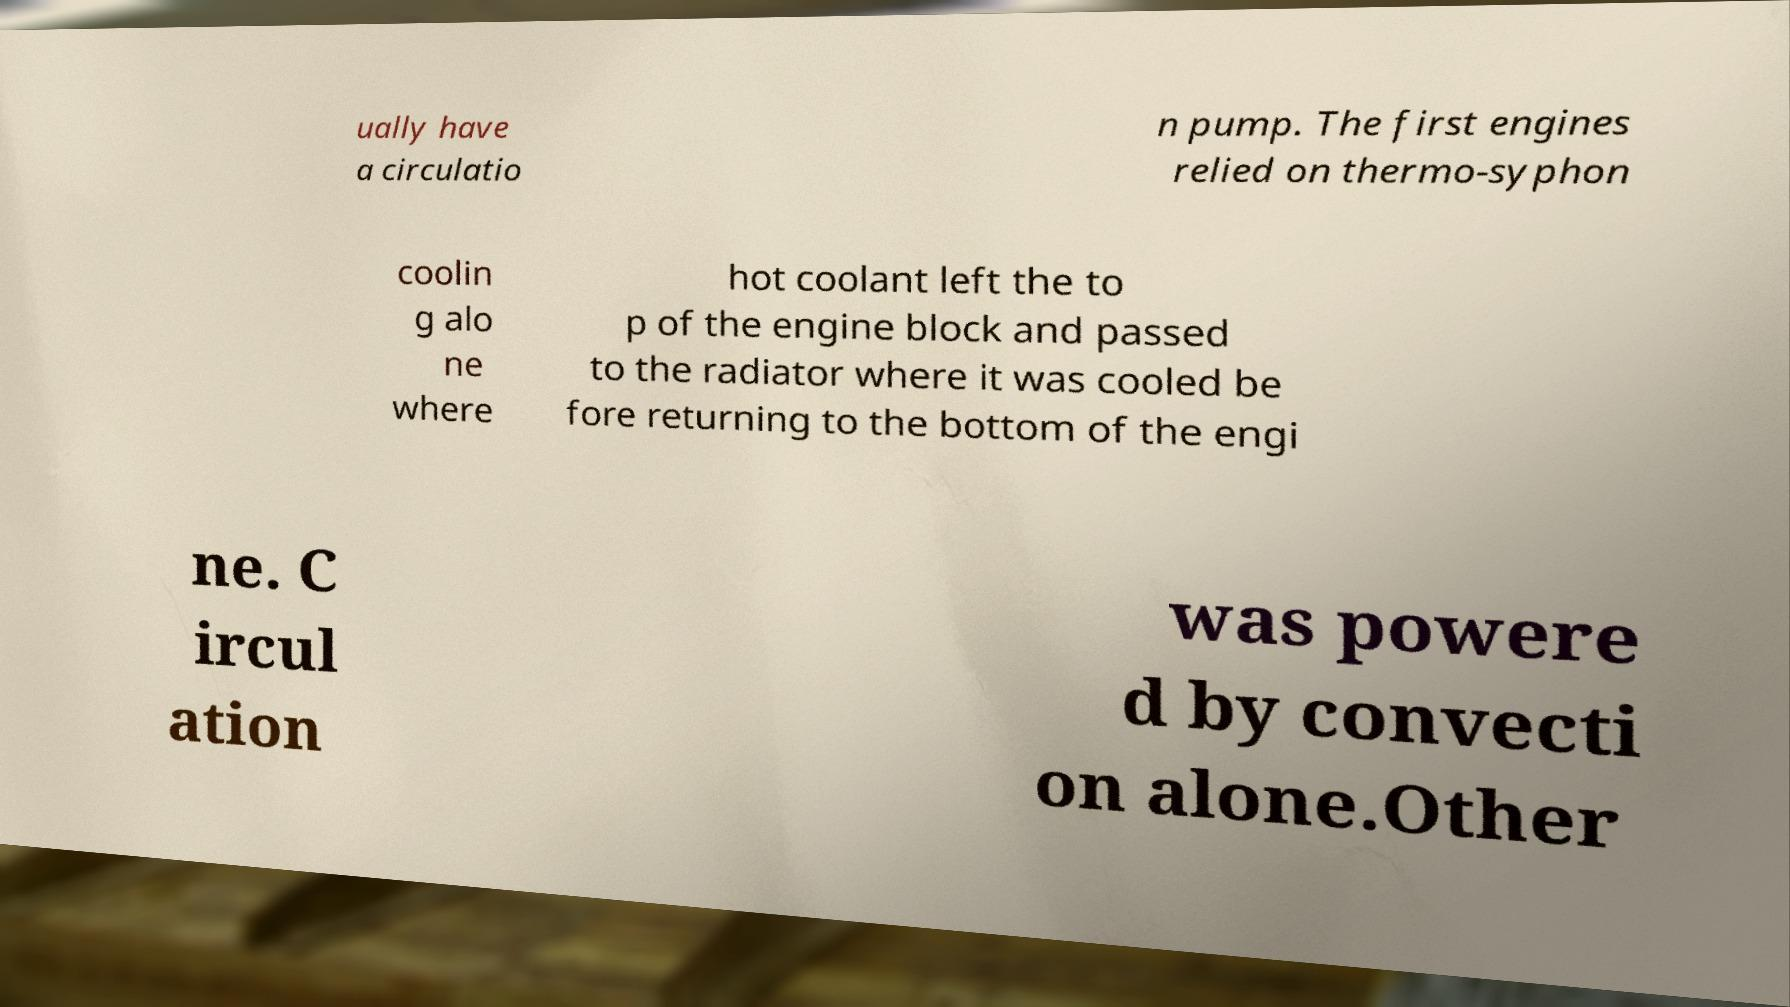Please identify and transcribe the text found in this image. ually have a circulatio n pump. The first engines relied on thermo-syphon coolin g alo ne where hot coolant left the to p of the engine block and passed to the radiator where it was cooled be fore returning to the bottom of the engi ne. C ircul ation was powere d by convecti on alone.Other 